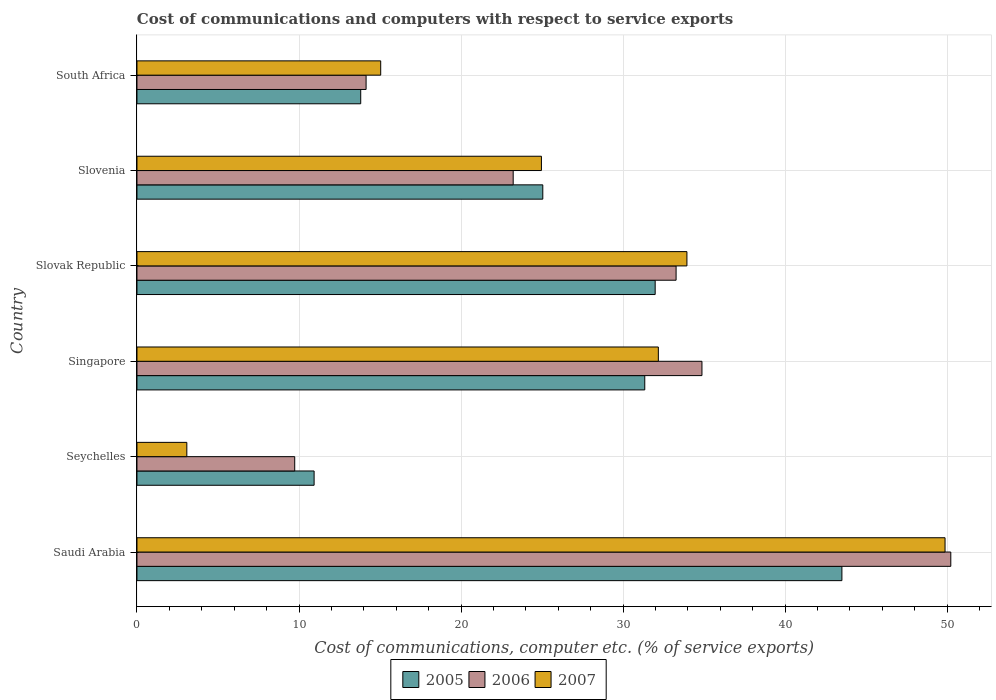How many different coloured bars are there?
Keep it short and to the point. 3. How many bars are there on the 3rd tick from the top?
Offer a very short reply. 3. How many bars are there on the 5th tick from the bottom?
Provide a succinct answer. 3. What is the label of the 5th group of bars from the top?
Make the answer very short. Seychelles. In how many cases, is the number of bars for a given country not equal to the number of legend labels?
Ensure brevity in your answer.  0. What is the cost of communications and computers in 2007 in Singapore?
Offer a very short reply. 32.18. Across all countries, what is the maximum cost of communications and computers in 2005?
Provide a short and direct response. 43.5. Across all countries, what is the minimum cost of communications and computers in 2005?
Make the answer very short. 10.93. In which country was the cost of communications and computers in 2007 maximum?
Ensure brevity in your answer.  Saudi Arabia. In which country was the cost of communications and computers in 2007 minimum?
Your answer should be compact. Seychelles. What is the total cost of communications and computers in 2006 in the graph?
Make the answer very short. 165.46. What is the difference between the cost of communications and computers in 2005 in Slovenia and that in South Africa?
Make the answer very short. 11.24. What is the difference between the cost of communications and computers in 2006 in Slovak Republic and the cost of communications and computers in 2005 in Singapore?
Your response must be concise. 1.93. What is the average cost of communications and computers in 2006 per country?
Provide a short and direct response. 27.58. What is the difference between the cost of communications and computers in 2007 and cost of communications and computers in 2006 in Slovenia?
Give a very brief answer. 1.74. What is the ratio of the cost of communications and computers in 2006 in Seychelles to that in Slovenia?
Offer a very short reply. 0.42. Is the cost of communications and computers in 2006 in Saudi Arabia less than that in Slovak Republic?
Offer a very short reply. No. Is the difference between the cost of communications and computers in 2007 in Seychelles and Singapore greater than the difference between the cost of communications and computers in 2006 in Seychelles and Singapore?
Your response must be concise. No. What is the difference between the highest and the second highest cost of communications and computers in 2005?
Your response must be concise. 11.52. What is the difference between the highest and the lowest cost of communications and computers in 2006?
Ensure brevity in your answer.  40.49. In how many countries, is the cost of communications and computers in 2007 greater than the average cost of communications and computers in 2007 taken over all countries?
Provide a succinct answer. 3. What does the 2nd bar from the top in Saudi Arabia represents?
Make the answer very short. 2006. How many bars are there?
Ensure brevity in your answer.  18. How many countries are there in the graph?
Keep it short and to the point. 6. Are the values on the major ticks of X-axis written in scientific E-notation?
Provide a succinct answer. No. Where does the legend appear in the graph?
Provide a succinct answer. Bottom center. How many legend labels are there?
Provide a succinct answer. 3. How are the legend labels stacked?
Your answer should be very brief. Horizontal. What is the title of the graph?
Provide a succinct answer. Cost of communications and computers with respect to service exports. Does "1978" appear as one of the legend labels in the graph?
Your answer should be compact. No. What is the label or title of the X-axis?
Provide a succinct answer. Cost of communications, computer etc. (% of service exports). What is the Cost of communications, computer etc. (% of service exports) of 2005 in Saudi Arabia?
Provide a succinct answer. 43.5. What is the Cost of communications, computer etc. (% of service exports) of 2006 in Saudi Arabia?
Ensure brevity in your answer.  50.22. What is the Cost of communications, computer etc. (% of service exports) in 2007 in Saudi Arabia?
Offer a terse response. 49.87. What is the Cost of communications, computer etc. (% of service exports) of 2005 in Seychelles?
Your answer should be very brief. 10.93. What is the Cost of communications, computer etc. (% of service exports) in 2006 in Seychelles?
Ensure brevity in your answer.  9.74. What is the Cost of communications, computer etc. (% of service exports) of 2007 in Seychelles?
Offer a terse response. 3.08. What is the Cost of communications, computer etc. (% of service exports) in 2005 in Singapore?
Ensure brevity in your answer.  31.34. What is the Cost of communications, computer etc. (% of service exports) in 2006 in Singapore?
Give a very brief answer. 34.87. What is the Cost of communications, computer etc. (% of service exports) in 2007 in Singapore?
Provide a short and direct response. 32.18. What is the Cost of communications, computer etc. (% of service exports) in 2005 in Slovak Republic?
Keep it short and to the point. 31.98. What is the Cost of communications, computer etc. (% of service exports) of 2006 in Slovak Republic?
Provide a succinct answer. 33.27. What is the Cost of communications, computer etc. (% of service exports) in 2007 in Slovak Republic?
Provide a succinct answer. 33.94. What is the Cost of communications, computer etc. (% of service exports) in 2005 in Slovenia?
Your answer should be very brief. 25.05. What is the Cost of communications, computer etc. (% of service exports) of 2006 in Slovenia?
Your answer should be compact. 23.22. What is the Cost of communications, computer etc. (% of service exports) of 2007 in Slovenia?
Offer a terse response. 24.96. What is the Cost of communications, computer etc. (% of service exports) in 2005 in South Africa?
Your answer should be compact. 13.81. What is the Cost of communications, computer etc. (% of service exports) of 2006 in South Africa?
Keep it short and to the point. 14.14. What is the Cost of communications, computer etc. (% of service exports) of 2007 in South Africa?
Provide a short and direct response. 15.04. Across all countries, what is the maximum Cost of communications, computer etc. (% of service exports) in 2005?
Make the answer very short. 43.5. Across all countries, what is the maximum Cost of communications, computer etc. (% of service exports) of 2006?
Offer a terse response. 50.22. Across all countries, what is the maximum Cost of communications, computer etc. (% of service exports) of 2007?
Your answer should be compact. 49.87. Across all countries, what is the minimum Cost of communications, computer etc. (% of service exports) of 2005?
Offer a very short reply. 10.93. Across all countries, what is the minimum Cost of communications, computer etc. (% of service exports) of 2006?
Provide a short and direct response. 9.74. Across all countries, what is the minimum Cost of communications, computer etc. (% of service exports) of 2007?
Make the answer very short. 3.08. What is the total Cost of communications, computer etc. (% of service exports) in 2005 in the graph?
Offer a terse response. 156.61. What is the total Cost of communications, computer etc. (% of service exports) of 2006 in the graph?
Provide a short and direct response. 165.46. What is the total Cost of communications, computer etc. (% of service exports) in 2007 in the graph?
Provide a short and direct response. 159.07. What is the difference between the Cost of communications, computer etc. (% of service exports) in 2005 in Saudi Arabia and that in Seychelles?
Keep it short and to the point. 32.57. What is the difference between the Cost of communications, computer etc. (% of service exports) of 2006 in Saudi Arabia and that in Seychelles?
Provide a succinct answer. 40.49. What is the difference between the Cost of communications, computer etc. (% of service exports) in 2007 in Saudi Arabia and that in Seychelles?
Give a very brief answer. 46.79. What is the difference between the Cost of communications, computer etc. (% of service exports) of 2005 in Saudi Arabia and that in Singapore?
Your response must be concise. 12.17. What is the difference between the Cost of communications, computer etc. (% of service exports) of 2006 in Saudi Arabia and that in Singapore?
Offer a terse response. 15.36. What is the difference between the Cost of communications, computer etc. (% of service exports) of 2007 in Saudi Arabia and that in Singapore?
Ensure brevity in your answer.  17.69. What is the difference between the Cost of communications, computer etc. (% of service exports) of 2005 in Saudi Arabia and that in Slovak Republic?
Offer a very short reply. 11.52. What is the difference between the Cost of communications, computer etc. (% of service exports) of 2006 in Saudi Arabia and that in Slovak Republic?
Give a very brief answer. 16.95. What is the difference between the Cost of communications, computer etc. (% of service exports) of 2007 in Saudi Arabia and that in Slovak Republic?
Your answer should be very brief. 15.93. What is the difference between the Cost of communications, computer etc. (% of service exports) of 2005 in Saudi Arabia and that in Slovenia?
Ensure brevity in your answer.  18.46. What is the difference between the Cost of communications, computer etc. (% of service exports) of 2006 in Saudi Arabia and that in Slovenia?
Provide a short and direct response. 27.01. What is the difference between the Cost of communications, computer etc. (% of service exports) in 2007 in Saudi Arabia and that in Slovenia?
Offer a terse response. 24.91. What is the difference between the Cost of communications, computer etc. (% of service exports) in 2005 in Saudi Arabia and that in South Africa?
Keep it short and to the point. 29.7. What is the difference between the Cost of communications, computer etc. (% of service exports) in 2006 in Saudi Arabia and that in South Africa?
Ensure brevity in your answer.  36.08. What is the difference between the Cost of communications, computer etc. (% of service exports) in 2007 in Saudi Arabia and that in South Africa?
Make the answer very short. 34.83. What is the difference between the Cost of communications, computer etc. (% of service exports) of 2005 in Seychelles and that in Singapore?
Give a very brief answer. -20.41. What is the difference between the Cost of communications, computer etc. (% of service exports) of 2006 in Seychelles and that in Singapore?
Provide a succinct answer. -25.13. What is the difference between the Cost of communications, computer etc. (% of service exports) in 2007 in Seychelles and that in Singapore?
Keep it short and to the point. -29.1. What is the difference between the Cost of communications, computer etc. (% of service exports) of 2005 in Seychelles and that in Slovak Republic?
Offer a terse response. -21.05. What is the difference between the Cost of communications, computer etc. (% of service exports) in 2006 in Seychelles and that in Slovak Republic?
Your answer should be very brief. -23.54. What is the difference between the Cost of communications, computer etc. (% of service exports) in 2007 in Seychelles and that in Slovak Republic?
Offer a terse response. -30.86. What is the difference between the Cost of communications, computer etc. (% of service exports) of 2005 in Seychelles and that in Slovenia?
Provide a short and direct response. -14.11. What is the difference between the Cost of communications, computer etc. (% of service exports) of 2006 in Seychelles and that in Slovenia?
Make the answer very short. -13.48. What is the difference between the Cost of communications, computer etc. (% of service exports) in 2007 in Seychelles and that in Slovenia?
Give a very brief answer. -21.88. What is the difference between the Cost of communications, computer etc. (% of service exports) of 2005 in Seychelles and that in South Africa?
Keep it short and to the point. -2.88. What is the difference between the Cost of communications, computer etc. (% of service exports) in 2006 in Seychelles and that in South Africa?
Offer a very short reply. -4.4. What is the difference between the Cost of communications, computer etc. (% of service exports) in 2007 in Seychelles and that in South Africa?
Keep it short and to the point. -11.96. What is the difference between the Cost of communications, computer etc. (% of service exports) in 2005 in Singapore and that in Slovak Republic?
Offer a very short reply. -0.64. What is the difference between the Cost of communications, computer etc. (% of service exports) of 2006 in Singapore and that in Slovak Republic?
Ensure brevity in your answer.  1.6. What is the difference between the Cost of communications, computer etc. (% of service exports) of 2007 in Singapore and that in Slovak Republic?
Your answer should be compact. -1.76. What is the difference between the Cost of communications, computer etc. (% of service exports) in 2005 in Singapore and that in Slovenia?
Provide a succinct answer. 6.29. What is the difference between the Cost of communications, computer etc. (% of service exports) in 2006 in Singapore and that in Slovenia?
Provide a short and direct response. 11.65. What is the difference between the Cost of communications, computer etc. (% of service exports) in 2007 in Singapore and that in Slovenia?
Keep it short and to the point. 7.22. What is the difference between the Cost of communications, computer etc. (% of service exports) of 2005 in Singapore and that in South Africa?
Ensure brevity in your answer.  17.53. What is the difference between the Cost of communications, computer etc. (% of service exports) in 2006 in Singapore and that in South Africa?
Your response must be concise. 20.73. What is the difference between the Cost of communications, computer etc. (% of service exports) in 2007 in Singapore and that in South Africa?
Your answer should be very brief. 17.13. What is the difference between the Cost of communications, computer etc. (% of service exports) in 2005 in Slovak Republic and that in Slovenia?
Give a very brief answer. 6.94. What is the difference between the Cost of communications, computer etc. (% of service exports) in 2006 in Slovak Republic and that in Slovenia?
Make the answer very short. 10.05. What is the difference between the Cost of communications, computer etc. (% of service exports) of 2007 in Slovak Republic and that in Slovenia?
Your answer should be very brief. 8.98. What is the difference between the Cost of communications, computer etc. (% of service exports) in 2005 in Slovak Republic and that in South Africa?
Give a very brief answer. 18.17. What is the difference between the Cost of communications, computer etc. (% of service exports) in 2006 in Slovak Republic and that in South Africa?
Give a very brief answer. 19.13. What is the difference between the Cost of communications, computer etc. (% of service exports) in 2007 in Slovak Republic and that in South Africa?
Your answer should be very brief. 18.9. What is the difference between the Cost of communications, computer etc. (% of service exports) of 2005 in Slovenia and that in South Africa?
Ensure brevity in your answer.  11.24. What is the difference between the Cost of communications, computer etc. (% of service exports) in 2006 in Slovenia and that in South Africa?
Keep it short and to the point. 9.08. What is the difference between the Cost of communications, computer etc. (% of service exports) in 2007 in Slovenia and that in South Africa?
Offer a terse response. 9.92. What is the difference between the Cost of communications, computer etc. (% of service exports) of 2005 in Saudi Arabia and the Cost of communications, computer etc. (% of service exports) of 2006 in Seychelles?
Your answer should be compact. 33.77. What is the difference between the Cost of communications, computer etc. (% of service exports) in 2005 in Saudi Arabia and the Cost of communications, computer etc. (% of service exports) in 2007 in Seychelles?
Provide a short and direct response. 40.43. What is the difference between the Cost of communications, computer etc. (% of service exports) in 2006 in Saudi Arabia and the Cost of communications, computer etc. (% of service exports) in 2007 in Seychelles?
Give a very brief answer. 47.15. What is the difference between the Cost of communications, computer etc. (% of service exports) in 2005 in Saudi Arabia and the Cost of communications, computer etc. (% of service exports) in 2006 in Singapore?
Keep it short and to the point. 8.64. What is the difference between the Cost of communications, computer etc. (% of service exports) of 2005 in Saudi Arabia and the Cost of communications, computer etc. (% of service exports) of 2007 in Singapore?
Ensure brevity in your answer.  11.33. What is the difference between the Cost of communications, computer etc. (% of service exports) in 2006 in Saudi Arabia and the Cost of communications, computer etc. (% of service exports) in 2007 in Singapore?
Provide a short and direct response. 18.05. What is the difference between the Cost of communications, computer etc. (% of service exports) in 2005 in Saudi Arabia and the Cost of communications, computer etc. (% of service exports) in 2006 in Slovak Republic?
Your response must be concise. 10.23. What is the difference between the Cost of communications, computer etc. (% of service exports) in 2005 in Saudi Arabia and the Cost of communications, computer etc. (% of service exports) in 2007 in Slovak Republic?
Ensure brevity in your answer.  9.56. What is the difference between the Cost of communications, computer etc. (% of service exports) in 2006 in Saudi Arabia and the Cost of communications, computer etc. (% of service exports) in 2007 in Slovak Republic?
Provide a succinct answer. 16.28. What is the difference between the Cost of communications, computer etc. (% of service exports) of 2005 in Saudi Arabia and the Cost of communications, computer etc. (% of service exports) of 2006 in Slovenia?
Make the answer very short. 20.29. What is the difference between the Cost of communications, computer etc. (% of service exports) in 2005 in Saudi Arabia and the Cost of communications, computer etc. (% of service exports) in 2007 in Slovenia?
Make the answer very short. 18.54. What is the difference between the Cost of communications, computer etc. (% of service exports) in 2006 in Saudi Arabia and the Cost of communications, computer etc. (% of service exports) in 2007 in Slovenia?
Provide a short and direct response. 25.26. What is the difference between the Cost of communications, computer etc. (% of service exports) of 2005 in Saudi Arabia and the Cost of communications, computer etc. (% of service exports) of 2006 in South Africa?
Your answer should be very brief. 29.36. What is the difference between the Cost of communications, computer etc. (% of service exports) in 2005 in Saudi Arabia and the Cost of communications, computer etc. (% of service exports) in 2007 in South Africa?
Provide a short and direct response. 28.46. What is the difference between the Cost of communications, computer etc. (% of service exports) in 2006 in Saudi Arabia and the Cost of communications, computer etc. (% of service exports) in 2007 in South Africa?
Provide a short and direct response. 35.18. What is the difference between the Cost of communications, computer etc. (% of service exports) of 2005 in Seychelles and the Cost of communications, computer etc. (% of service exports) of 2006 in Singapore?
Keep it short and to the point. -23.94. What is the difference between the Cost of communications, computer etc. (% of service exports) of 2005 in Seychelles and the Cost of communications, computer etc. (% of service exports) of 2007 in Singapore?
Make the answer very short. -21.24. What is the difference between the Cost of communications, computer etc. (% of service exports) in 2006 in Seychelles and the Cost of communications, computer etc. (% of service exports) in 2007 in Singapore?
Your response must be concise. -22.44. What is the difference between the Cost of communications, computer etc. (% of service exports) of 2005 in Seychelles and the Cost of communications, computer etc. (% of service exports) of 2006 in Slovak Republic?
Your answer should be compact. -22.34. What is the difference between the Cost of communications, computer etc. (% of service exports) in 2005 in Seychelles and the Cost of communications, computer etc. (% of service exports) in 2007 in Slovak Republic?
Make the answer very short. -23.01. What is the difference between the Cost of communications, computer etc. (% of service exports) in 2006 in Seychelles and the Cost of communications, computer etc. (% of service exports) in 2007 in Slovak Republic?
Your response must be concise. -24.2. What is the difference between the Cost of communications, computer etc. (% of service exports) of 2005 in Seychelles and the Cost of communications, computer etc. (% of service exports) of 2006 in Slovenia?
Provide a succinct answer. -12.29. What is the difference between the Cost of communications, computer etc. (% of service exports) in 2005 in Seychelles and the Cost of communications, computer etc. (% of service exports) in 2007 in Slovenia?
Ensure brevity in your answer.  -14.03. What is the difference between the Cost of communications, computer etc. (% of service exports) in 2006 in Seychelles and the Cost of communications, computer etc. (% of service exports) in 2007 in Slovenia?
Provide a succinct answer. -15.22. What is the difference between the Cost of communications, computer etc. (% of service exports) of 2005 in Seychelles and the Cost of communications, computer etc. (% of service exports) of 2006 in South Africa?
Provide a succinct answer. -3.21. What is the difference between the Cost of communications, computer etc. (% of service exports) of 2005 in Seychelles and the Cost of communications, computer etc. (% of service exports) of 2007 in South Africa?
Give a very brief answer. -4.11. What is the difference between the Cost of communications, computer etc. (% of service exports) of 2006 in Seychelles and the Cost of communications, computer etc. (% of service exports) of 2007 in South Africa?
Offer a very short reply. -5.31. What is the difference between the Cost of communications, computer etc. (% of service exports) of 2005 in Singapore and the Cost of communications, computer etc. (% of service exports) of 2006 in Slovak Republic?
Your answer should be compact. -1.93. What is the difference between the Cost of communications, computer etc. (% of service exports) in 2005 in Singapore and the Cost of communications, computer etc. (% of service exports) in 2007 in Slovak Republic?
Give a very brief answer. -2.6. What is the difference between the Cost of communications, computer etc. (% of service exports) of 2006 in Singapore and the Cost of communications, computer etc. (% of service exports) of 2007 in Slovak Republic?
Your response must be concise. 0.93. What is the difference between the Cost of communications, computer etc. (% of service exports) of 2005 in Singapore and the Cost of communications, computer etc. (% of service exports) of 2006 in Slovenia?
Offer a terse response. 8.12. What is the difference between the Cost of communications, computer etc. (% of service exports) in 2005 in Singapore and the Cost of communications, computer etc. (% of service exports) in 2007 in Slovenia?
Give a very brief answer. 6.38. What is the difference between the Cost of communications, computer etc. (% of service exports) in 2006 in Singapore and the Cost of communications, computer etc. (% of service exports) in 2007 in Slovenia?
Give a very brief answer. 9.91. What is the difference between the Cost of communications, computer etc. (% of service exports) in 2005 in Singapore and the Cost of communications, computer etc. (% of service exports) in 2006 in South Africa?
Your answer should be compact. 17.2. What is the difference between the Cost of communications, computer etc. (% of service exports) in 2005 in Singapore and the Cost of communications, computer etc. (% of service exports) in 2007 in South Africa?
Make the answer very short. 16.3. What is the difference between the Cost of communications, computer etc. (% of service exports) in 2006 in Singapore and the Cost of communications, computer etc. (% of service exports) in 2007 in South Africa?
Your answer should be compact. 19.83. What is the difference between the Cost of communications, computer etc. (% of service exports) of 2005 in Slovak Republic and the Cost of communications, computer etc. (% of service exports) of 2006 in Slovenia?
Give a very brief answer. 8.76. What is the difference between the Cost of communications, computer etc. (% of service exports) of 2005 in Slovak Republic and the Cost of communications, computer etc. (% of service exports) of 2007 in Slovenia?
Offer a very short reply. 7.02. What is the difference between the Cost of communications, computer etc. (% of service exports) in 2006 in Slovak Republic and the Cost of communications, computer etc. (% of service exports) in 2007 in Slovenia?
Offer a terse response. 8.31. What is the difference between the Cost of communications, computer etc. (% of service exports) in 2005 in Slovak Republic and the Cost of communications, computer etc. (% of service exports) in 2006 in South Africa?
Provide a short and direct response. 17.84. What is the difference between the Cost of communications, computer etc. (% of service exports) of 2005 in Slovak Republic and the Cost of communications, computer etc. (% of service exports) of 2007 in South Africa?
Offer a terse response. 16.94. What is the difference between the Cost of communications, computer etc. (% of service exports) in 2006 in Slovak Republic and the Cost of communications, computer etc. (% of service exports) in 2007 in South Africa?
Your answer should be very brief. 18.23. What is the difference between the Cost of communications, computer etc. (% of service exports) in 2005 in Slovenia and the Cost of communications, computer etc. (% of service exports) in 2006 in South Africa?
Offer a very short reply. 10.9. What is the difference between the Cost of communications, computer etc. (% of service exports) in 2005 in Slovenia and the Cost of communications, computer etc. (% of service exports) in 2007 in South Africa?
Offer a terse response. 10. What is the difference between the Cost of communications, computer etc. (% of service exports) in 2006 in Slovenia and the Cost of communications, computer etc. (% of service exports) in 2007 in South Africa?
Your answer should be very brief. 8.18. What is the average Cost of communications, computer etc. (% of service exports) of 2005 per country?
Your response must be concise. 26.1. What is the average Cost of communications, computer etc. (% of service exports) of 2006 per country?
Offer a very short reply. 27.58. What is the average Cost of communications, computer etc. (% of service exports) in 2007 per country?
Offer a terse response. 26.51. What is the difference between the Cost of communications, computer etc. (% of service exports) in 2005 and Cost of communications, computer etc. (% of service exports) in 2006 in Saudi Arabia?
Your answer should be very brief. -6.72. What is the difference between the Cost of communications, computer etc. (% of service exports) in 2005 and Cost of communications, computer etc. (% of service exports) in 2007 in Saudi Arabia?
Your answer should be very brief. -6.37. What is the difference between the Cost of communications, computer etc. (% of service exports) in 2006 and Cost of communications, computer etc. (% of service exports) in 2007 in Saudi Arabia?
Offer a very short reply. 0.36. What is the difference between the Cost of communications, computer etc. (% of service exports) of 2005 and Cost of communications, computer etc. (% of service exports) of 2006 in Seychelles?
Provide a short and direct response. 1.2. What is the difference between the Cost of communications, computer etc. (% of service exports) in 2005 and Cost of communications, computer etc. (% of service exports) in 2007 in Seychelles?
Your answer should be compact. 7.85. What is the difference between the Cost of communications, computer etc. (% of service exports) in 2006 and Cost of communications, computer etc. (% of service exports) in 2007 in Seychelles?
Give a very brief answer. 6.66. What is the difference between the Cost of communications, computer etc. (% of service exports) of 2005 and Cost of communications, computer etc. (% of service exports) of 2006 in Singapore?
Provide a succinct answer. -3.53. What is the difference between the Cost of communications, computer etc. (% of service exports) in 2005 and Cost of communications, computer etc. (% of service exports) in 2007 in Singapore?
Your answer should be compact. -0.84. What is the difference between the Cost of communications, computer etc. (% of service exports) in 2006 and Cost of communications, computer etc. (% of service exports) in 2007 in Singapore?
Keep it short and to the point. 2.69. What is the difference between the Cost of communications, computer etc. (% of service exports) in 2005 and Cost of communications, computer etc. (% of service exports) in 2006 in Slovak Republic?
Give a very brief answer. -1.29. What is the difference between the Cost of communications, computer etc. (% of service exports) of 2005 and Cost of communications, computer etc. (% of service exports) of 2007 in Slovak Republic?
Make the answer very short. -1.96. What is the difference between the Cost of communications, computer etc. (% of service exports) in 2006 and Cost of communications, computer etc. (% of service exports) in 2007 in Slovak Republic?
Provide a succinct answer. -0.67. What is the difference between the Cost of communications, computer etc. (% of service exports) of 2005 and Cost of communications, computer etc. (% of service exports) of 2006 in Slovenia?
Provide a short and direct response. 1.83. What is the difference between the Cost of communications, computer etc. (% of service exports) of 2005 and Cost of communications, computer etc. (% of service exports) of 2007 in Slovenia?
Make the answer very short. 0.09. What is the difference between the Cost of communications, computer etc. (% of service exports) in 2006 and Cost of communications, computer etc. (% of service exports) in 2007 in Slovenia?
Your answer should be very brief. -1.74. What is the difference between the Cost of communications, computer etc. (% of service exports) of 2005 and Cost of communications, computer etc. (% of service exports) of 2006 in South Africa?
Ensure brevity in your answer.  -0.33. What is the difference between the Cost of communications, computer etc. (% of service exports) of 2005 and Cost of communications, computer etc. (% of service exports) of 2007 in South Africa?
Ensure brevity in your answer.  -1.23. What is the difference between the Cost of communications, computer etc. (% of service exports) in 2006 and Cost of communications, computer etc. (% of service exports) in 2007 in South Africa?
Your answer should be very brief. -0.9. What is the ratio of the Cost of communications, computer etc. (% of service exports) in 2005 in Saudi Arabia to that in Seychelles?
Your answer should be compact. 3.98. What is the ratio of the Cost of communications, computer etc. (% of service exports) in 2006 in Saudi Arabia to that in Seychelles?
Ensure brevity in your answer.  5.16. What is the ratio of the Cost of communications, computer etc. (% of service exports) in 2007 in Saudi Arabia to that in Seychelles?
Offer a terse response. 16.2. What is the ratio of the Cost of communications, computer etc. (% of service exports) in 2005 in Saudi Arabia to that in Singapore?
Ensure brevity in your answer.  1.39. What is the ratio of the Cost of communications, computer etc. (% of service exports) of 2006 in Saudi Arabia to that in Singapore?
Provide a short and direct response. 1.44. What is the ratio of the Cost of communications, computer etc. (% of service exports) in 2007 in Saudi Arabia to that in Singapore?
Your answer should be compact. 1.55. What is the ratio of the Cost of communications, computer etc. (% of service exports) of 2005 in Saudi Arabia to that in Slovak Republic?
Your answer should be compact. 1.36. What is the ratio of the Cost of communications, computer etc. (% of service exports) in 2006 in Saudi Arabia to that in Slovak Republic?
Offer a terse response. 1.51. What is the ratio of the Cost of communications, computer etc. (% of service exports) of 2007 in Saudi Arabia to that in Slovak Republic?
Ensure brevity in your answer.  1.47. What is the ratio of the Cost of communications, computer etc. (% of service exports) of 2005 in Saudi Arabia to that in Slovenia?
Provide a short and direct response. 1.74. What is the ratio of the Cost of communications, computer etc. (% of service exports) of 2006 in Saudi Arabia to that in Slovenia?
Your answer should be very brief. 2.16. What is the ratio of the Cost of communications, computer etc. (% of service exports) of 2007 in Saudi Arabia to that in Slovenia?
Make the answer very short. 2. What is the ratio of the Cost of communications, computer etc. (% of service exports) of 2005 in Saudi Arabia to that in South Africa?
Your answer should be compact. 3.15. What is the ratio of the Cost of communications, computer etc. (% of service exports) in 2006 in Saudi Arabia to that in South Africa?
Offer a very short reply. 3.55. What is the ratio of the Cost of communications, computer etc. (% of service exports) in 2007 in Saudi Arabia to that in South Africa?
Keep it short and to the point. 3.32. What is the ratio of the Cost of communications, computer etc. (% of service exports) of 2005 in Seychelles to that in Singapore?
Ensure brevity in your answer.  0.35. What is the ratio of the Cost of communications, computer etc. (% of service exports) of 2006 in Seychelles to that in Singapore?
Provide a succinct answer. 0.28. What is the ratio of the Cost of communications, computer etc. (% of service exports) of 2007 in Seychelles to that in Singapore?
Offer a very short reply. 0.1. What is the ratio of the Cost of communications, computer etc. (% of service exports) in 2005 in Seychelles to that in Slovak Republic?
Keep it short and to the point. 0.34. What is the ratio of the Cost of communications, computer etc. (% of service exports) in 2006 in Seychelles to that in Slovak Republic?
Provide a succinct answer. 0.29. What is the ratio of the Cost of communications, computer etc. (% of service exports) in 2007 in Seychelles to that in Slovak Republic?
Provide a short and direct response. 0.09. What is the ratio of the Cost of communications, computer etc. (% of service exports) in 2005 in Seychelles to that in Slovenia?
Provide a succinct answer. 0.44. What is the ratio of the Cost of communications, computer etc. (% of service exports) of 2006 in Seychelles to that in Slovenia?
Offer a terse response. 0.42. What is the ratio of the Cost of communications, computer etc. (% of service exports) of 2007 in Seychelles to that in Slovenia?
Ensure brevity in your answer.  0.12. What is the ratio of the Cost of communications, computer etc. (% of service exports) in 2005 in Seychelles to that in South Africa?
Provide a succinct answer. 0.79. What is the ratio of the Cost of communications, computer etc. (% of service exports) of 2006 in Seychelles to that in South Africa?
Your answer should be compact. 0.69. What is the ratio of the Cost of communications, computer etc. (% of service exports) in 2007 in Seychelles to that in South Africa?
Your answer should be very brief. 0.2. What is the ratio of the Cost of communications, computer etc. (% of service exports) of 2005 in Singapore to that in Slovak Republic?
Provide a succinct answer. 0.98. What is the ratio of the Cost of communications, computer etc. (% of service exports) of 2006 in Singapore to that in Slovak Republic?
Provide a succinct answer. 1.05. What is the ratio of the Cost of communications, computer etc. (% of service exports) in 2007 in Singapore to that in Slovak Republic?
Provide a succinct answer. 0.95. What is the ratio of the Cost of communications, computer etc. (% of service exports) of 2005 in Singapore to that in Slovenia?
Your answer should be very brief. 1.25. What is the ratio of the Cost of communications, computer etc. (% of service exports) of 2006 in Singapore to that in Slovenia?
Your response must be concise. 1.5. What is the ratio of the Cost of communications, computer etc. (% of service exports) of 2007 in Singapore to that in Slovenia?
Ensure brevity in your answer.  1.29. What is the ratio of the Cost of communications, computer etc. (% of service exports) in 2005 in Singapore to that in South Africa?
Offer a very short reply. 2.27. What is the ratio of the Cost of communications, computer etc. (% of service exports) in 2006 in Singapore to that in South Africa?
Keep it short and to the point. 2.47. What is the ratio of the Cost of communications, computer etc. (% of service exports) in 2007 in Singapore to that in South Africa?
Your answer should be very brief. 2.14. What is the ratio of the Cost of communications, computer etc. (% of service exports) of 2005 in Slovak Republic to that in Slovenia?
Make the answer very short. 1.28. What is the ratio of the Cost of communications, computer etc. (% of service exports) in 2006 in Slovak Republic to that in Slovenia?
Give a very brief answer. 1.43. What is the ratio of the Cost of communications, computer etc. (% of service exports) of 2007 in Slovak Republic to that in Slovenia?
Your answer should be compact. 1.36. What is the ratio of the Cost of communications, computer etc. (% of service exports) of 2005 in Slovak Republic to that in South Africa?
Ensure brevity in your answer.  2.32. What is the ratio of the Cost of communications, computer etc. (% of service exports) of 2006 in Slovak Republic to that in South Africa?
Your response must be concise. 2.35. What is the ratio of the Cost of communications, computer etc. (% of service exports) in 2007 in Slovak Republic to that in South Africa?
Your response must be concise. 2.26. What is the ratio of the Cost of communications, computer etc. (% of service exports) in 2005 in Slovenia to that in South Africa?
Give a very brief answer. 1.81. What is the ratio of the Cost of communications, computer etc. (% of service exports) of 2006 in Slovenia to that in South Africa?
Your response must be concise. 1.64. What is the ratio of the Cost of communications, computer etc. (% of service exports) in 2007 in Slovenia to that in South Africa?
Make the answer very short. 1.66. What is the difference between the highest and the second highest Cost of communications, computer etc. (% of service exports) in 2005?
Offer a very short reply. 11.52. What is the difference between the highest and the second highest Cost of communications, computer etc. (% of service exports) in 2006?
Make the answer very short. 15.36. What is the difference between the highest and the second highest Cost of communications, computer etc. (% of service exports) of 2007?
Your response must be concise. 15.93. What is the difference between the highest and the lowest Cost of communications, computer etc. (% of service exports) of 2005?
Provide a short and direct response. 32.57. What is the difference between the highest and the lowest Cost of communications, computer etc. (% of service exports) of 2006?
Your answer should be compact. 40.49. What is the difference between the highest and the lowest Cost of communications, computer etc. (% of service exports) in 2007?
Provide a short and direct response. 46.79. 